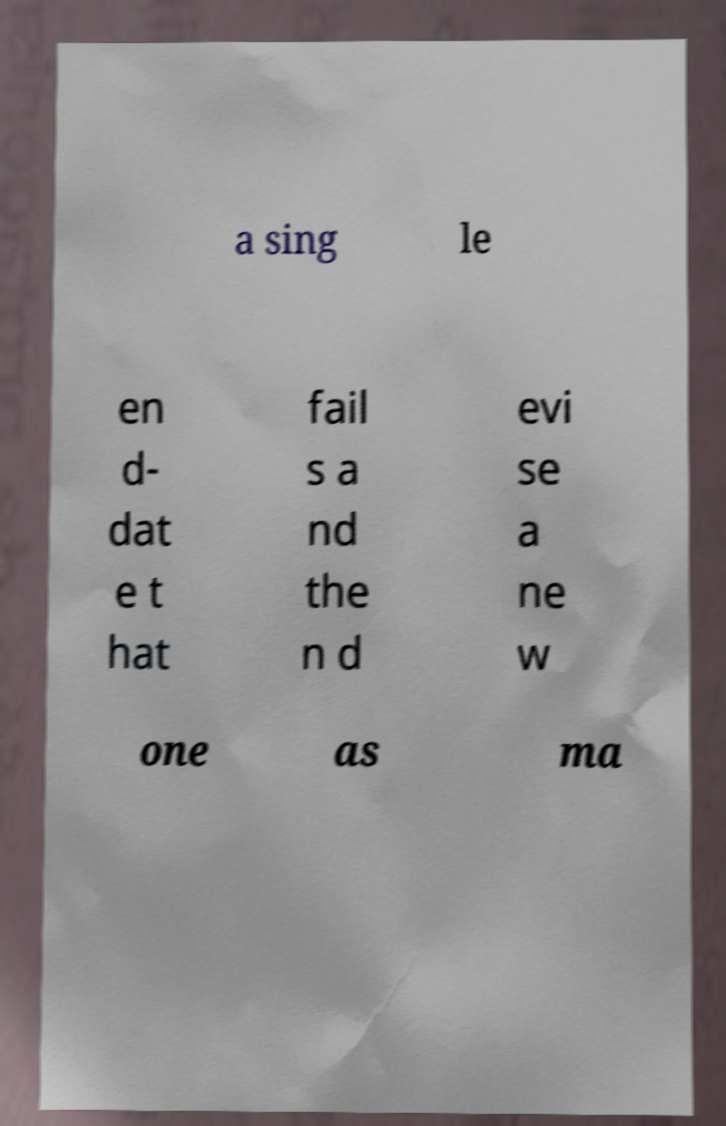I need the written content from this picture converted into text. Can you do that? a sing le en d- dat e t hat fail s a nd the n d evi se a ne w one as ma 